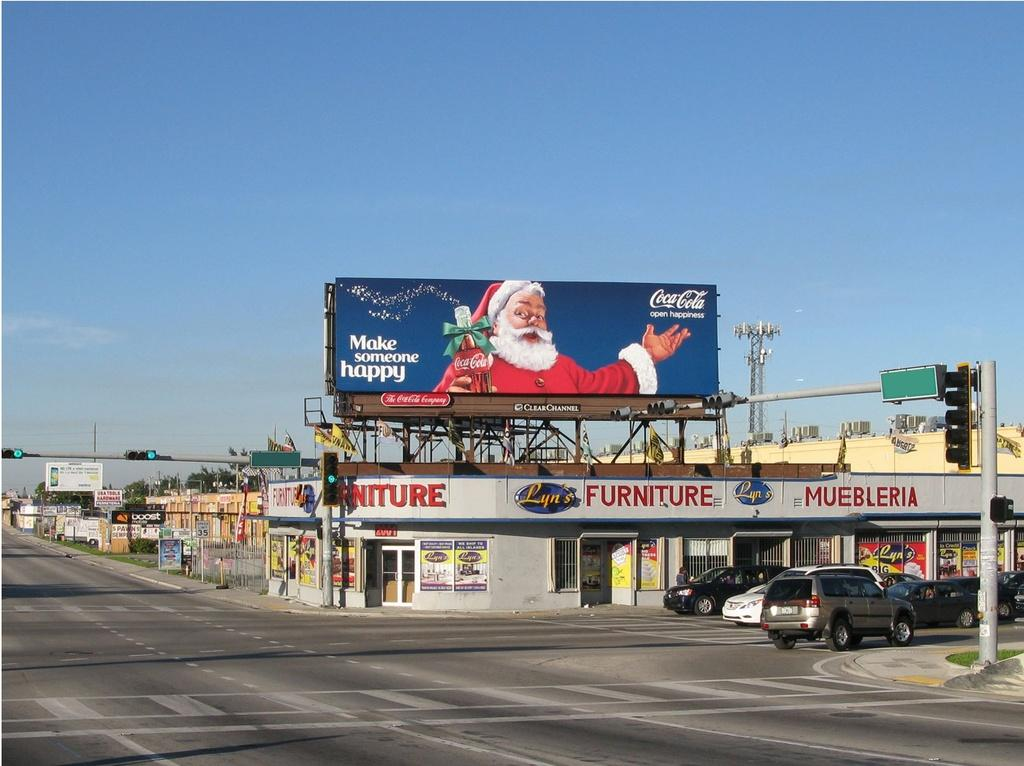Provide a one-sentence caption for the provided image. The Coca Cola sign on a furniture store on a street corner has the image of Santa on it. 